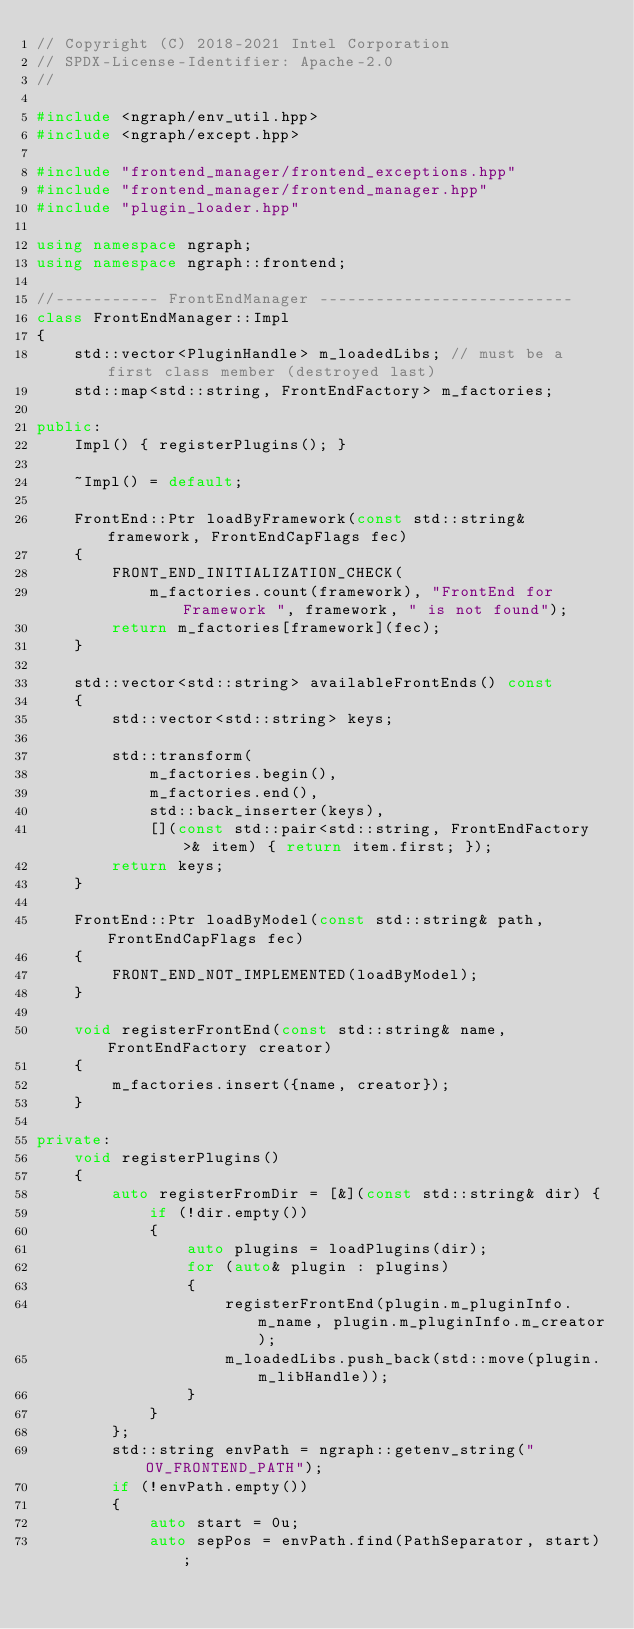Convert code to text. <code><loc_0><loc_0><loc_500><loc_500><_C++_>// Copyright (C) 2018-2021 Intel Corporation
// SPDX-License-Identifier: Apache-2.0
//

#include <ngraph/env_util.hpp>
#include <ngraph/except.hpp>

#include "frontend_manager/frontend_exceptions.hpp"
#include "frontend_manager/frontend_manager.hpp"
#include "plugin_loader.hpp"

using namespace ngraph;
using namespace ngraph::frontend;

//----------- FrontEndManager ---------------------------
class FrontEndManager::Impl
{
    std::vector<PluginHandle> m_loadedLibs; // must be a first class member (destroyed last)
    std::map<std::string, FrontEndFactory> m_factories;

public:
    Impl() { registerPlugins(); }

    ~Impl() = default;

    FrontEnd::Ptr loadByFramework(const std::string& framework, FrontEndCapFlags fec)
    {
        FRONT_END_INITIALIZATION_CHECK(
            m_factories.count(framework), "FrontEnd for Framework ", framework, " is not found");
        return m_factories[framework](fec);
    }

    std::vector<std::string> availableFrontEnds() const
    {
        std::vector<std::string> keys;

        std::transform(
            m_factories.begin(),
            m_factories.end(),
            std::back_inserter(keys),
            [](const std::pair<std::string, FrontEndFactory>& item) { return item.first; });
        return keys;
    }

    FrontEnd::Ptr loadByModel(const std::string& path, FrontEndCapFlags fec)
    {
        FRONT_END_NOT_IMPLEMENTED(loadByModel);
    }

    void registerFrontEnd(const std::string& name, FrontEndFactory creator)
    {
        m_factories.insert({name, creator});
    }

private:
    void registerPlugins()
    {
        auto registerFromDir = [&](const std::string& dir) {
            if (!dir.empty())
            {
                auto plugins = loadPlugins(dir);
                for (auto& plugin : plugins)
                {
                    registerFrontEnd(plugin.m_pluginInfo.m_name, plugin.m_pluginInfo.m_creator);
                    m_loadedLibs.push_back(std::move(plugin.m_libHandle));
                }
            }
        };
        std::string envPath = ngraph::getenv_string("OV_FRONTEND_PATH");
        if (!envPath.empty())
        {
            auto start = 0u;
            auto sepPos = envPath.find(PathSeparator, start);</code> 